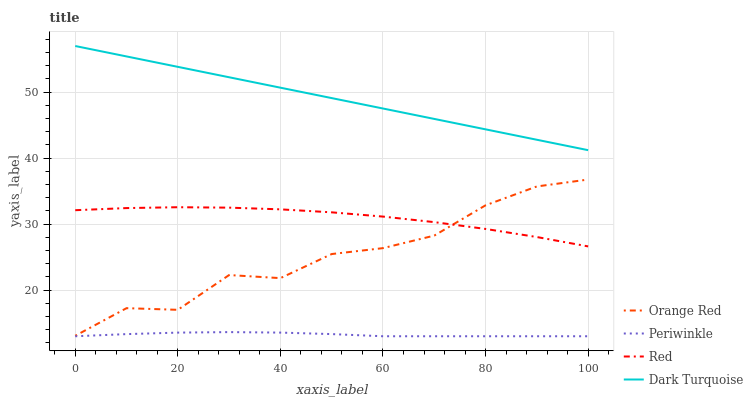Does Orange Red have the minimum area under the curve?
Answer yes or no. No. Does Orange Red have the maximum area under the curve?
Answer yes or no. No. Is Periwinkle the smoothest?
Answer yes or no. No. Is Periwinkle the roughest?
Answer yes or no. No. Does Orange Red have the lowest value?
Answer yes or no. No. Does Orange Red have the highest value?
Answer yes or no. No. Is Periwinkle less than Orange Red?
Answer yes or no. Yes. Is Dark Turquoise greater than Periwinkle?
Answer yes or no. Yes. Does Periwinkle intersect Orange Red?
Answer yes or no. No. 